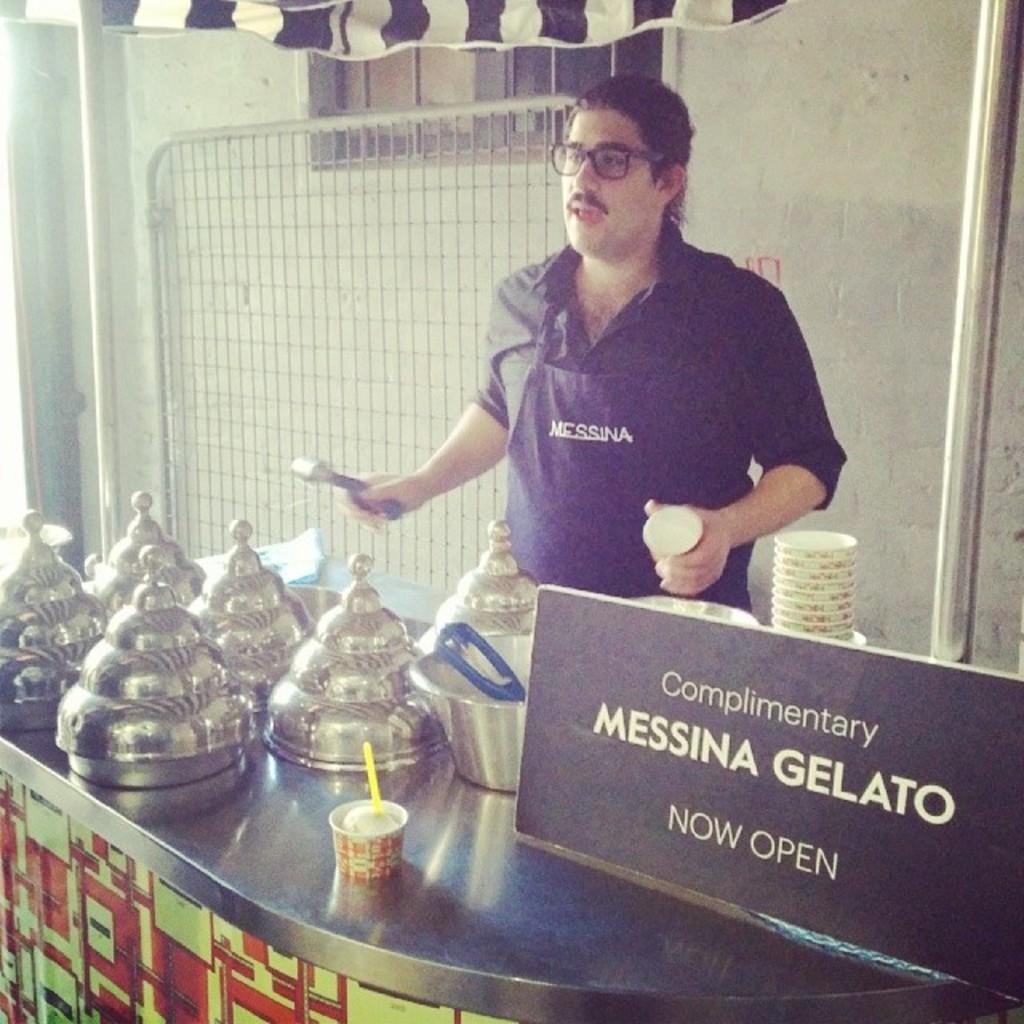Can you describe this image briefly? In this image there is a man in the middle who is holding the cup with one hand and a spoon with another hand. In front of him there are so many vessels. On the right side there is a board. At the bottom there is a cup on the metal desk. In the background there is a grill. At the top there is tent. On the right side there is an iron rod, Beside the road there are cups. 